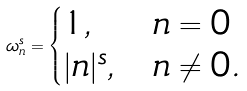<formula> <loc_0><loc_0><loc_500><loc_500>\omega _ { n } ^ { s } = \begin{cases} 1 , & n = 0 \\ | n | ^ { s } , & n \neq 0 . \end{cases}</formula> 